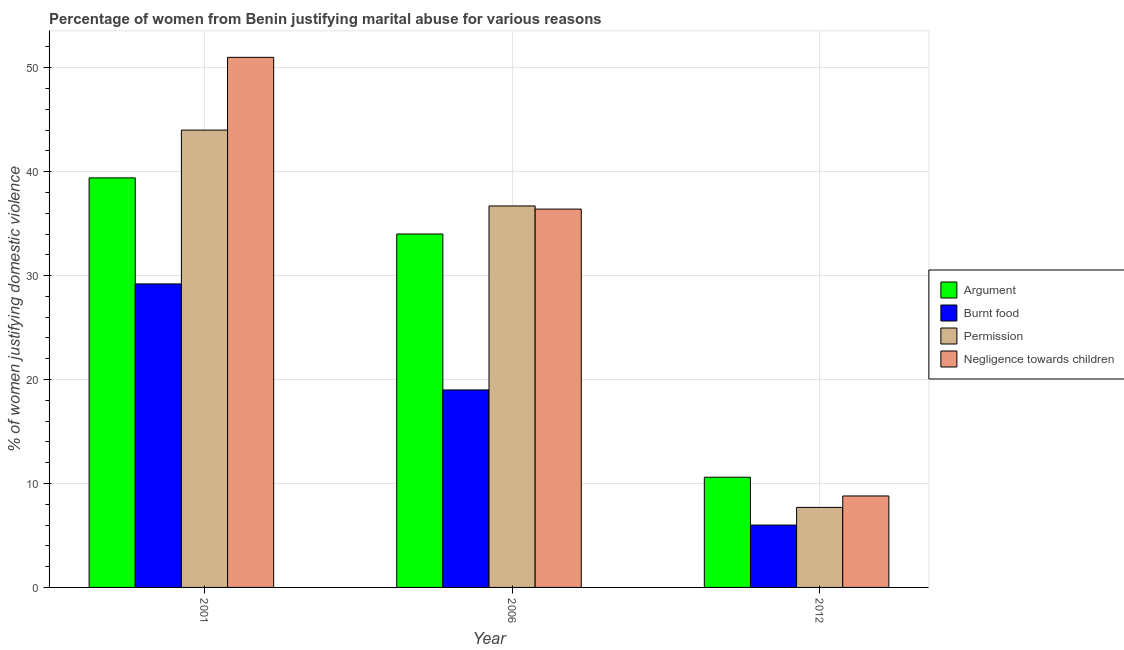How many bars are there on the 2nd tick from the left?
Your answer should be very brief. 4. What is the label of the 3rd group of bars from the left?
Offer a terse response. 2012. Across all years, what is the maximum percentage of women justifying abuse for burning food?
Offer a very short reply. 29.2. In which year was the percentage of women justifying abuse for showing negligence towards children maximum?
Provide a succinct answer. 2001. In which year was the percentage of women justifying abuse for going without permission minimum?
Ensure brevity in your answer.  2012. What is the total percentage of women justifying abuse for going without permission in the graph?
Your answer should be very brief. 88.4. What is the difference between the percentage of women justifying abuse for showing negligence towards children in 2001 and that in 2006?
Give a very brief answer. 14.6. What is the average percentage of women justifying abuse in the case of an argument per year?
Make the answer very short. 28. What is the ratio of the percentage of women justifying abuse in the case of an argument in 2001 to that in 2012?
Give a very brief answer. 3.72. Is the difference between the percentage of women justifying abuse in the case of an argument in 2006 and 2012 greater than the difference between the percentage of women justifying abuse for going without permission in 2006 and 2012?
Offer a terse response. No. What is the difference between the highest and the second highest percentage of women justifying abuse for burning food?
Your answer should be compact. 10.2. What is the difference between the highest and the lowest percentage of women justifying abuse in the case of an argument?
Provide a succinct answer. 28.8. Is the sum of the percentage of women justifying abuse for going without permission in 2006 and 2012 greater than the maximum percentage of women justifying abuse for showing negligence towards children across all years?
Offer a terse response. Yes. Is it the case that in every year, the sum of the percentage of women justifying abuse for showing negligence towards children and percentage of women justifying abuse in the case of an argument is greater than the sum of percentage of women justifying abuse for going without permission and percentage of women justifying abuse for burning food?
Your answer should be very brief. No. What does the 2nd bar from the left in 2001 represents?
Your answer should be very brief. Burnt food. What does the 4th bar from the right in 2012 represents?
Provide a short and direct response. Argument. How many years are there in the graph?
Offer a terse response. 3. Does the graph contain any zero values?
Offer a terse response. No. How many legend labels are there?
Offer a terse response. 4. How are the legend labels stacked?
Your answer should be compact. Vertical. What is the title of the graph?
Offer a very short reply. Percentage of women from Benin justifying marital abuse for various reasons. Does "Regional development banks" appear as one of the legend labels in the graph?
Provide a short and direct response. No. What is the label or title of the X-axis?
Your answer should be very brief. Year. What is the label or title of the Y-axis?
Offer a terse response. % of women justifying domestic violence. What is the % of women justifying domestic violence of Argument in 2001?
Give a very brief answer. 39.4. What is the % of women justifying domestic violence of Burnt food in 2001?
Provide a short and direct response. 29.2. What is the % of women justifying domestic violence of Argument in 2006?
Provide a succinct answer. 34. What is the % of women justifying domestic violence in Burnt food in 2006?
Ensure brevity in your answer.  19. What is the % of women justifying domestic violence in Permission in 2006?
Give a very brief answer. 36.7. What is the % of women justifying domestic violence in Negligence towards children in 2006?
Your response must be concise. 36.4. What is the % of women justifying domestic violence of Negligence towards children in 2012?
Your answer should be very brief. 8.8. Across all years, what is the maximum % of women justifying domestic violence in Argument?
Provide a succinct answer. 39.4. Across all years, what is the maximum % of women justifying domestic violence in Burnt food?
Provide a short and direct response. 29.2. Across all years, what is the maximum % of women justifying domestic violence in Permission?
Offer a terse response. 44. Across all years, what is the maximum % of women justifying domestic violence in Negligence towards children?
Provide a succinct answer. 51. Across all years, what is the minimum % of women justifying domestic violence of Permission?
Give a very brief answer. 7.7. What is the total % of women justifying domestic violence of Argument in the graph?
Your answer should be very brief. 84. What is the total % of women justifying domestic violence in Burnt food in the graph?
Your answer should be compact. 54.2. What is the total % of women justifying domestic violence in Permission in the graph?
Offer a terse response. 88.4. What is the total % of women justifying domestic violence in Negligence towards children in the graph?
Keep it short and to the point. 96.2. What is the difference between the % of women justifying domestic violence in Burnt food in 2001 and that in 2006?
Keep it short and to the point. 10.2. What is the difference between the % of women justifying domestic violence in Negligence towards children in 2001 and that in 2006?
Provide a short and direct response. 14.6. What is the difference between the % of women justifying domestic violence of Argument in 2001 and that in 2012?
Offer a terse response. 28.8. What is the difference between the % of women justifying domestic violence of Burnt food in 2001 and that in 2012?
Your answer should be very brief. 23.2. What is the difference between the % of women justifying domestic violence of Permission in 2001 and that in 2012?
Your answer should be very brief. 36.3. What is the difference between the % of women justifying domestic violence of Negligence towards children in 2001 and that in 2012?
Your answer should be very brief. 42.2. What is the difference between the % of women justifying domestic violence of Argument in 2006 and that in 2012?
Offer a very short reply. 23.4. What is the difference between the % of women justifying domestic violence of Burnt food in 2006 and that in 2012?
Your answer should be very brief. 13. What is the difference between the % of women justifying domestic violence of Permission in 2006 and that in 2012?
Your answer should be compact. 29. What is the difference between the % of women justifying domestic violence of Negligence towards children in 2006 and that in 2012?
Offer a very short reply. 27.6. What is the difference between the % of women justifying domestic violence in Argument in 2001 and the % of women justifying domestic violence in Burnt food in 2006?
Keep it short and to the point. 20.4. What is the difference between the % of women justifying domestic violence of Argument in 2001 and the % of women justifying domestic violence of Permission in 2006?
Provide a short and direct response. 2.7. What is the difference between the % of women justifying domestic violence of Argument in 2001 and the % of women justifying domestic violence of Negligence towards children in 2006?
Provide a short and direct response. 3. What is the difference between the % of women justifying domestic violence in Permission in 2001 and the % of women justifying domestic violence in Negligence towards children in 2006?
Your response must be concise. 7.6. What is the difference between the % of women justifying domestic violence in Argument in 2001 and the % of women justifying domestic violence in Burnt food in 2012?
Offer a terse response. 33.4. What is the difference between the % of women justifying domestic violence of Argument in 2001 and the % of women justifying domestic violence of Permission in 2012?
Ensure brevity in your answer.  31.7. What is the difference between the % of women justifying domestic violence in Argument in 2001 and the % of women justifying domestic violence in Negligence towards children in 2012?
Make the answer very short. 30.6. What is the difference between the % of women justifying domestic violence of Burnt food in 2001 and the % of women justifying domestic violence of Permission in 2012?
Keep it short and to the point. 21.5. What is the difference between the % of women justifying domestic violence in Burnt food in 2001 and the % of women justifying domestic violence in Negligence towards children in 2012?
Your answer should be compact. 20.4. What is the difference between the % of women justifying domestic violence in Permission in 2001 and the % of women justifying domestic violence in Negligence towards children in 2012?
Give a very brief answer. 35.2. What is the difference between the % of women justifying domestic violence of Argument in 2006 and the % of women justifying domestic violence of Burnt food in 2012?
Offer a very short reply. 28. What is the difference between the % of women justifying domestic violence of Argument in 2006 and the % of women justifying domestic violence of Permission in 2012?
Keep it short and to the point. 26.3. What is the difference between the % of women justifying domestic violence of Argument in 2006 and the % of women justifying domestic violence of Negligence towards children in 2012?
Give a very brief answer. 25.2. What is the difference between the % of women justifying domestic violence of Burnt food in 2006 and the % of women justifying domestic violence of Permission in 2012?
Provide a succinct answer. 11.3. What is the difference between the % of women justifying domestic violence of Burnt food in 2006 and the % of women justifying domestic violence of Negligence towards children in 2012?
Provide a short and direct response. 10.2. What is the difference between the % of women justifying domestic violence in Permission in 2006 and the % of women justifying domestic violence in Negligence towards children in 2012?
Ensure brevity in your answer.  27.9. What is the average % of women justifying domestic violence of Argument per year?
Offer a terse response. 28. What is the average % of women justifying domestic violence of Burnt food per year?
Your response must be concise. 18.07. What is the average % of women justifying domestic violence in Permission per year?
Ensure brevity in your answer.  29.47. What is the average % of women justifying domestic violence of Negligence towards children per year?
Provide a short and direct response. 32.07. In the year 2001, what is the difference between the % of women justifying domestic violence of Argument and % of women justifying domestic violence of Permission?
Your answer should be very brief. -4.6. In the year 2001, what is the difference between the % of women justifying domestic violence of Argument and % of women justifying domestic violence of Negligence towards children?
Your answer should be compact. -11.6. In the year 2001, what is the difference between the % of women justifying domestic violence in Burnt food and % of women justifying domestic violence in Permission?
Offer a terse response. -14.8. In the year 2001, what is the difference between the % of women justifying domestic violence in Burnt food and % of women justifying domestic violence in Negligence towards children?
Offer a very short reply. -21.8. In the year 2001, what is the difference between the % of women justifying domestic violence of Permission and % of women justifying domestic violence of Negligence towards children?
Make the answer very short. -7. In the year 2006, what is the difference between the % of women justifying domestic violence in Argument and % of women justifying domestic violence in Negligence towards children?
Provide a short and direct response. -2.4. In the year 2006, what is the difference between the % of women justifying domestic violence in Burnt food and % of women justifying domestic violence in Permission?
Your answer should be compact. -17.7. In the year 2006, what is the difference between the % of women justifying domestic violence in Burnt food and % of women justifying domestic violence in Negligence towards children?
Provide a succinct answer. -17.4. In the year 2006, what is the difference between the % of women justifying domestic violence of Permission and % of women justifying domestic violence of Negligence towards children?
Make the answer very short. 0.3. In the year 2012, what is the difference between the % of women justifying domestic violence in Argument and % of women justifying domestic violence in Permission?
Ensure brevity in your answer.  2.9. In the year 2012, what is the difference between the % of women justifying domestic violence in Argument and % of women justifying domestic violence in Negligence towards children?
Provide a short and direct response. 1.8. What is the ratio of the % of women justifying domestic violence in Argument in 2001 to that in 2006?
Your response must be concise. 1.16. What is the ratio of the % of women justifying domestic violence of Burnt food in 2001 to that in 2006?
Ensure brevity in your answer.  1.54. What is the ratio of the % of women justifying domestic violence in Permission in 2001 to that in 2006?
Provide a short and direct response. 1.2. What is the ratio of the % of women justifying domestic violence in Negligence towards children in 2001 to that in 2006?
Make the answer very short. 1.4. What is the ratio of the % of women justifying domestic violence in Argument in 2001 to that in 2012?
Make the answer very short. 3.72. What is the ratio of the % of women justifying domestic violence of Burnt food in 2001 to that in 2012?
Provide a succinct answer. 4.87. What is the ratio of the % of women justifying domestic violence of Permission in 2001 to that in 2012?
Your answer should be very brief. 5.71. What is the ratio of the % of women justifying domestic violence of Negligence towards children in 2001 to that in 2012?
Provide a succinct answer. 5.8. What is the ratio of the % of women justifying domestic violence in Argument in 2006 to that in 2012?
Keep it short and to the point. 3.21. What is the ratio of the % of women justifying domestic violence of Burnt food in 2006 to that in 2012?
Offer a very short reply. 3.17. What is the ratio of the % of women justifying domestic violence in Permission in 2006 to that in 2012?
Offer a terse response. 4.77. What is the ratio of the % of women justifying domestic violence in Negligence towards children in 2006 to that in 2012?
Give a very brief answer. 4.14. What is the difference between the highest and the second highest % of women justifying domestic violence in Burnt food?
Give a very brief answer. 10.2. What is the difference between the highest and the second highest % of women justifying domestic violence in Permission?
Make the answer very short. 7.3. What is the difference between the highest and the lowest % of women justifying domestic violence of Argument?
Your answer should be compact. 28.8. What is the difference between the highest and the lowest % of women justifying domestic violence in Burnt food?
Offer a very short reply. 23.2. What is the difference between the highest and the lowest % of women justifying domestic violence in Permission?
Provide a succinct answer. 36.3. What is the difference between the highest and the lowest % of women justifying domestic violence in Negligence towards children?
Keep it short and to the point. 42.2. 